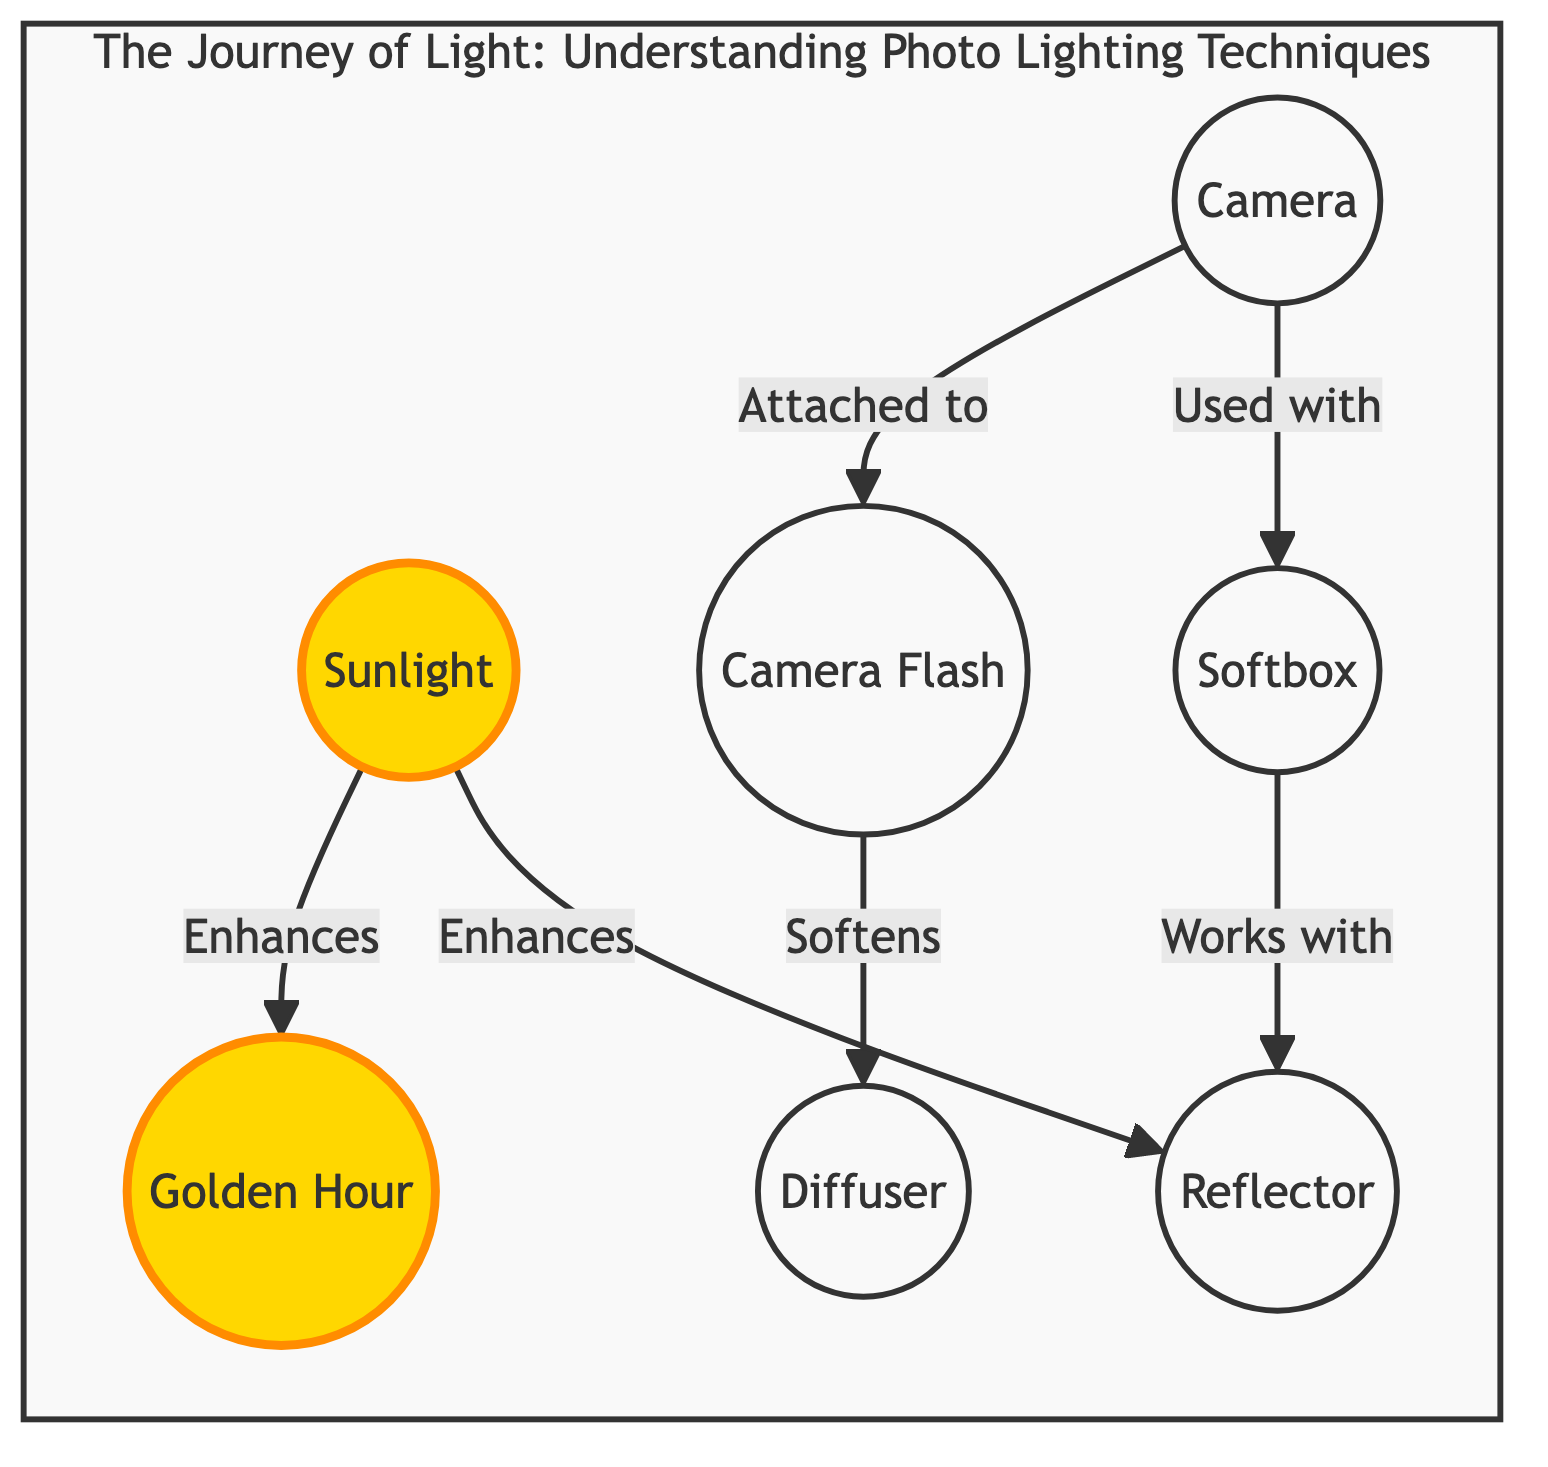What is the highlighted source of light in the diagram? The highlighted source of light is represented in the diagram under the node labeled 'Sunlight'.
Answer: Sunlight Which technique works with a reflector? In the diagram, 'Softbox' is indicated as working with a 'Reflector'.
Answer: Softbox How many techniques are involved in the diagram? By counting each node, there are six techniques represented in the diagram: Sunlight, Flash, Softbox, Reflector, Diffuser, and Golden Hour.
Answer: 6 What relation does the 'Camera' have with the 'Flash'? The diagram indicates that the 'Camera' is 'Attached to' the 'Flash', which shows the direct relationship between them.
Answer: Attached to Which lighting condition is enhanced by sunlight? The sunlight enhances the node labeled 'Golden Hour' in the diagram, indicating its importance during this time.
Answer: Golden Hour How does sunlight interact with the reflector? According to the diagram, sunlight 'Enhances' the 'Reflector', establishing a supportive relationship between them.
Answer: Enhances What lighting technique is used together with a softbox? The relationship shows that a 'Camera' is 'Used with' a 'Softbox', indicating their combination in use.
Answer: Camera What does flash do to the diffuser? The relationship depicted in the diagram suggests that 'Flash' 'Softens' the 'Diffuser', indicating its effect.
Answer: Softens What is the purpose of the 'Diffuser' in the diagram? The diagram explains that the 'Diffuser' is influenced by the 'Flash', showing its role in light manipulation.
Answer: Softens 